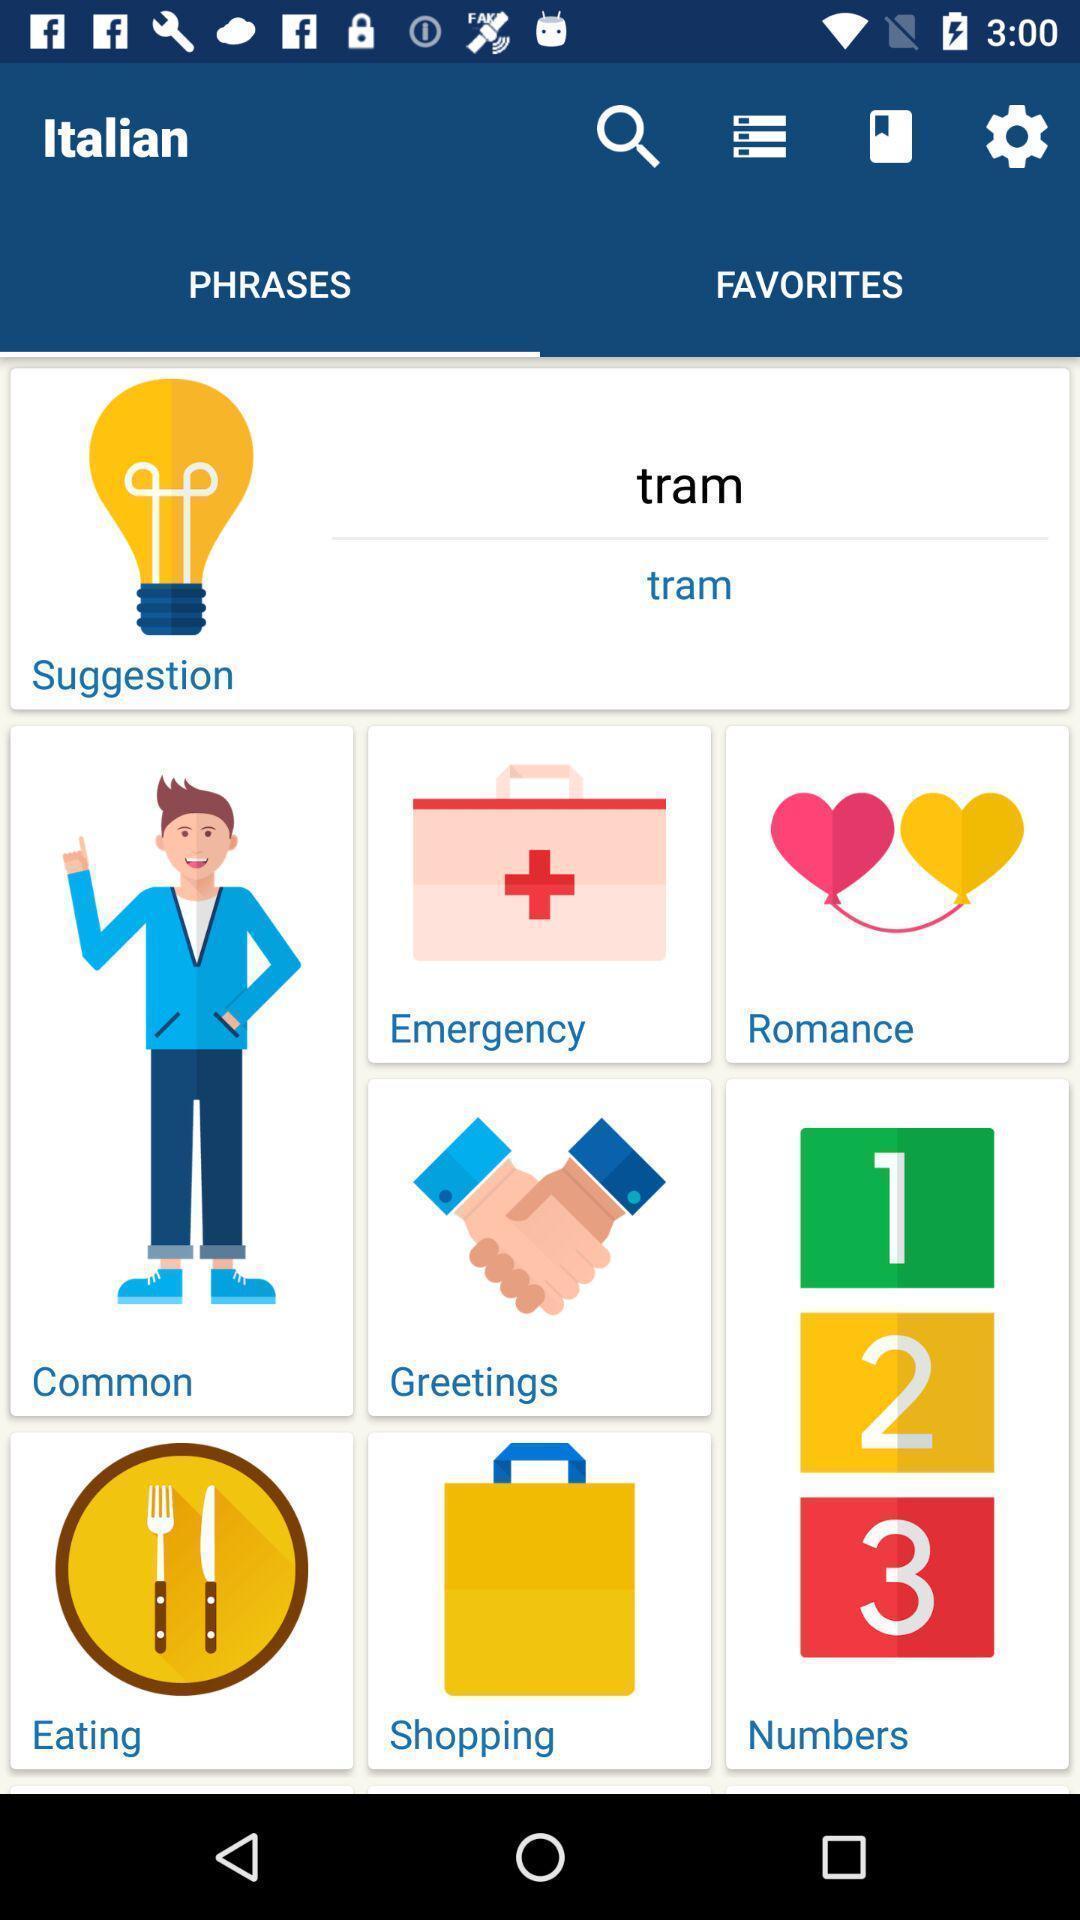Explain the elements present in this screenshot. Phrases page of an italian learning app. 